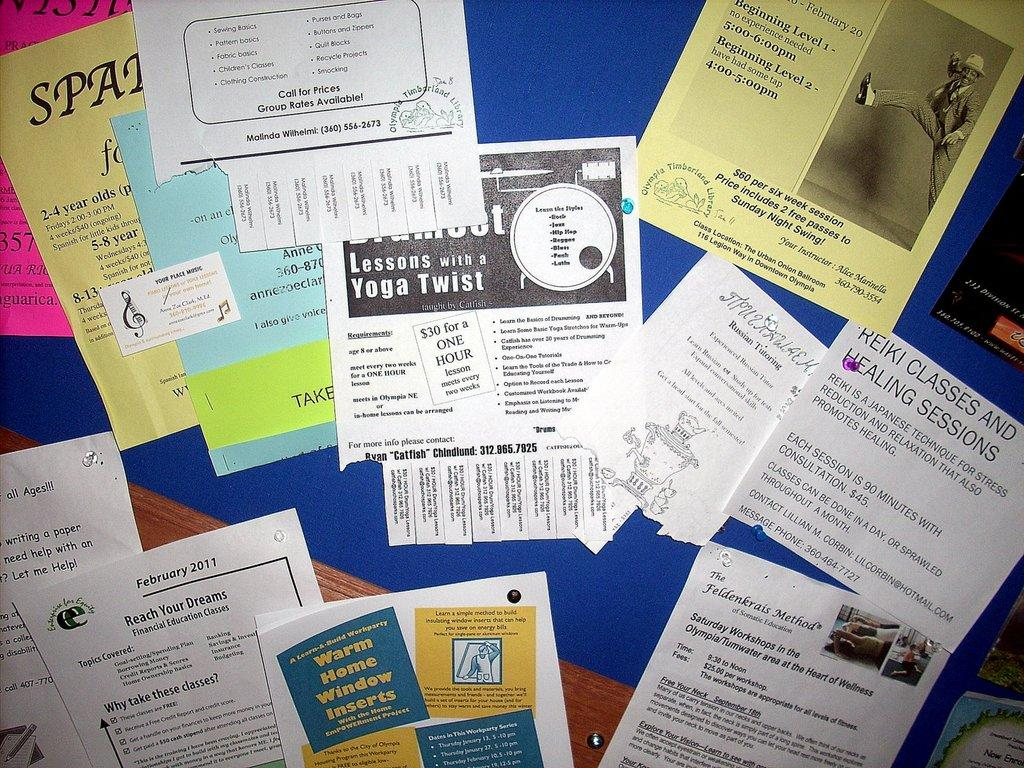What is on the board in the image? There are papers on a board in the image. Is there any wax visible on the board in the image? There is no wax present on the board in the image; only papers are visible. 